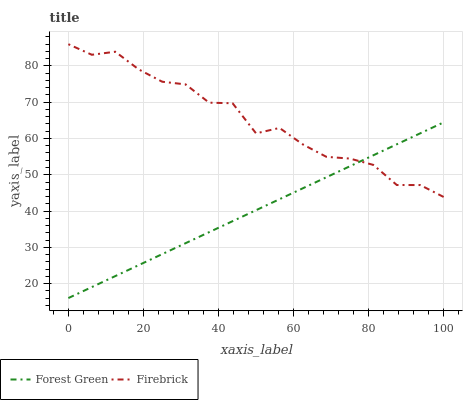Does Firebrick have the minimum area under the curve?
Answer yes or no. No. Is Firebrick the smoothest?
Answer yes or no. No. Does Firebrick have the lowest value?
Answer yes or no. No. 